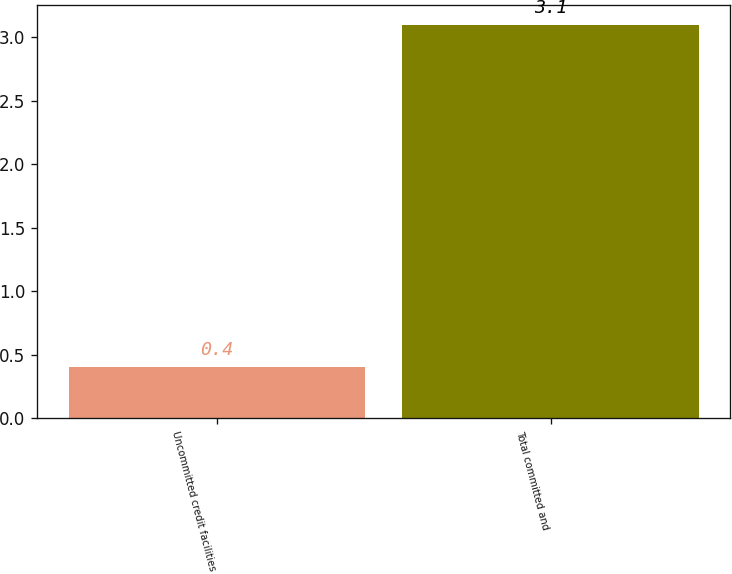Convert chart. <chart><loc_0><loc_0><loc_500><loc_500><bar_chart><fcel>Uncommitted credit facilities<fcel>Total committed and<nl><fcel>0.4<fcel>3.1<nl></chart> 